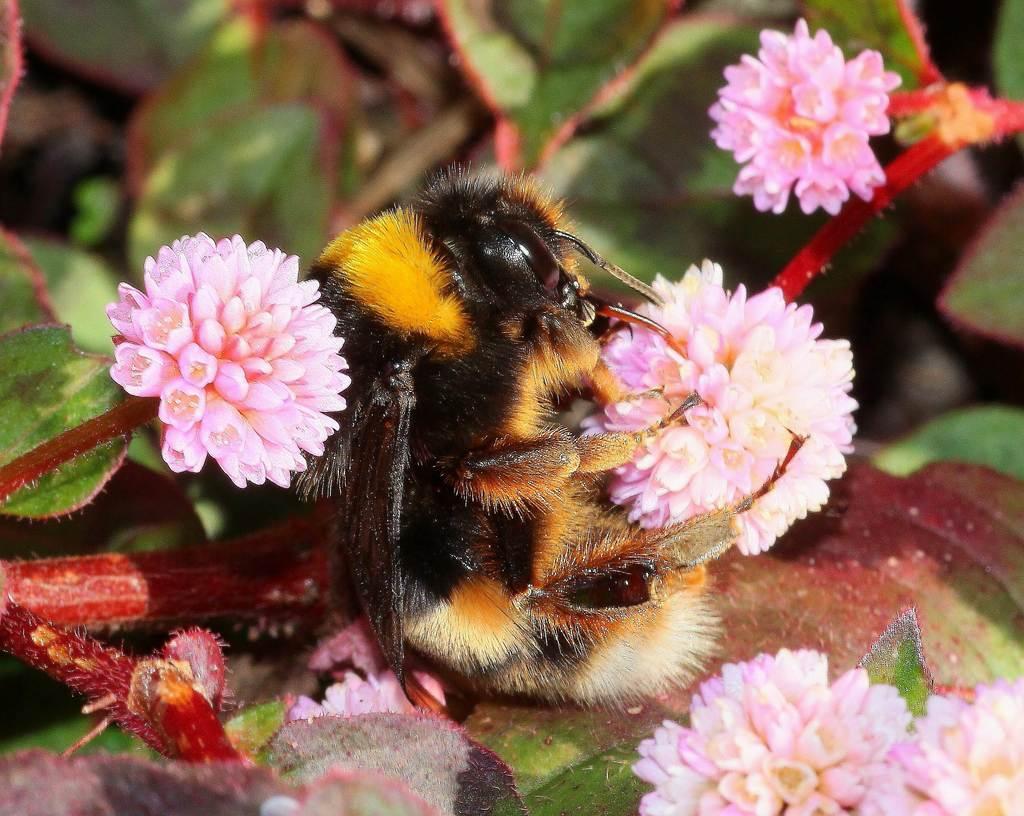Please provide a concise description of this image. In this image I can see an insect, flowers, leaves and stems. In the background of the image it is blurry.  